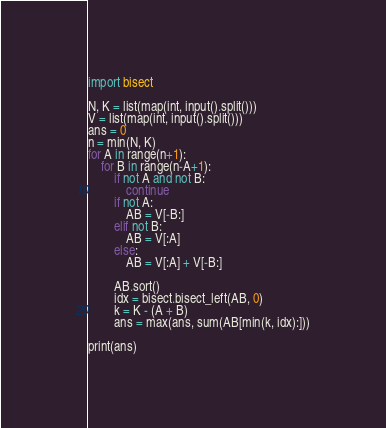Convert code to text. <code><loc_0><loc_0><loc_500><loc_500><_Python_>import bisect

N, K = list(map(int, input().split()))
V = list(map(int, input().split()))
ans = 0
n = min(N, K)
for A in range(n+1):
    for B in range(n-A+1):
        if not A and not B:
            continue
        if not A:
            AB = V[-B:]
        elif not B:
            AB = V[:A]
        else:
            AB = V[:A] + V[-B:]

        AB.sort()
        idx = bisect.bisect_left(AB, 0)
        k = K - (A + B)
        ans = max(ans, sum(AB[min(k, idx):]))

print(ans)</code> 